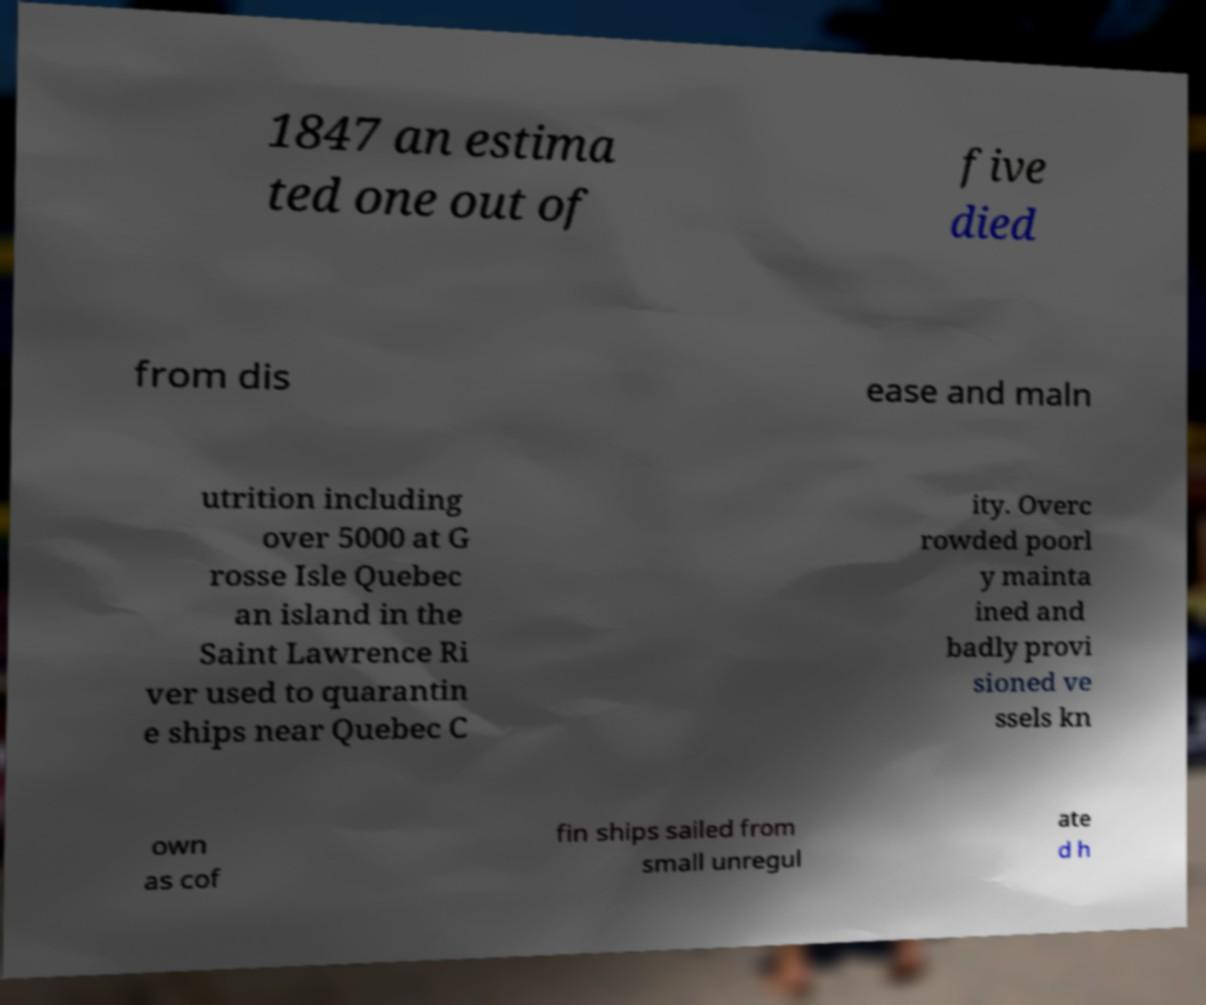What messages or text are displayed in this image? I need them in a readable, typed format. 1847 an estima ted one out of five died from dis ease and maln utrition including over 5000 at G rosse Isle Quebec an island in the Saint Lawrence Ri ver used to quarantin e ships near Quebec C ity. Overc rowded poorl y mainta ined and badly provi sioned ve ssels kn own as cof fin ships sailed from small unregul ate d h 